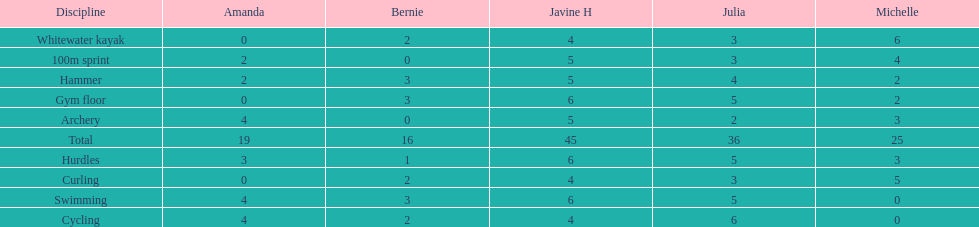Who had her best score in cycling? Julia. 